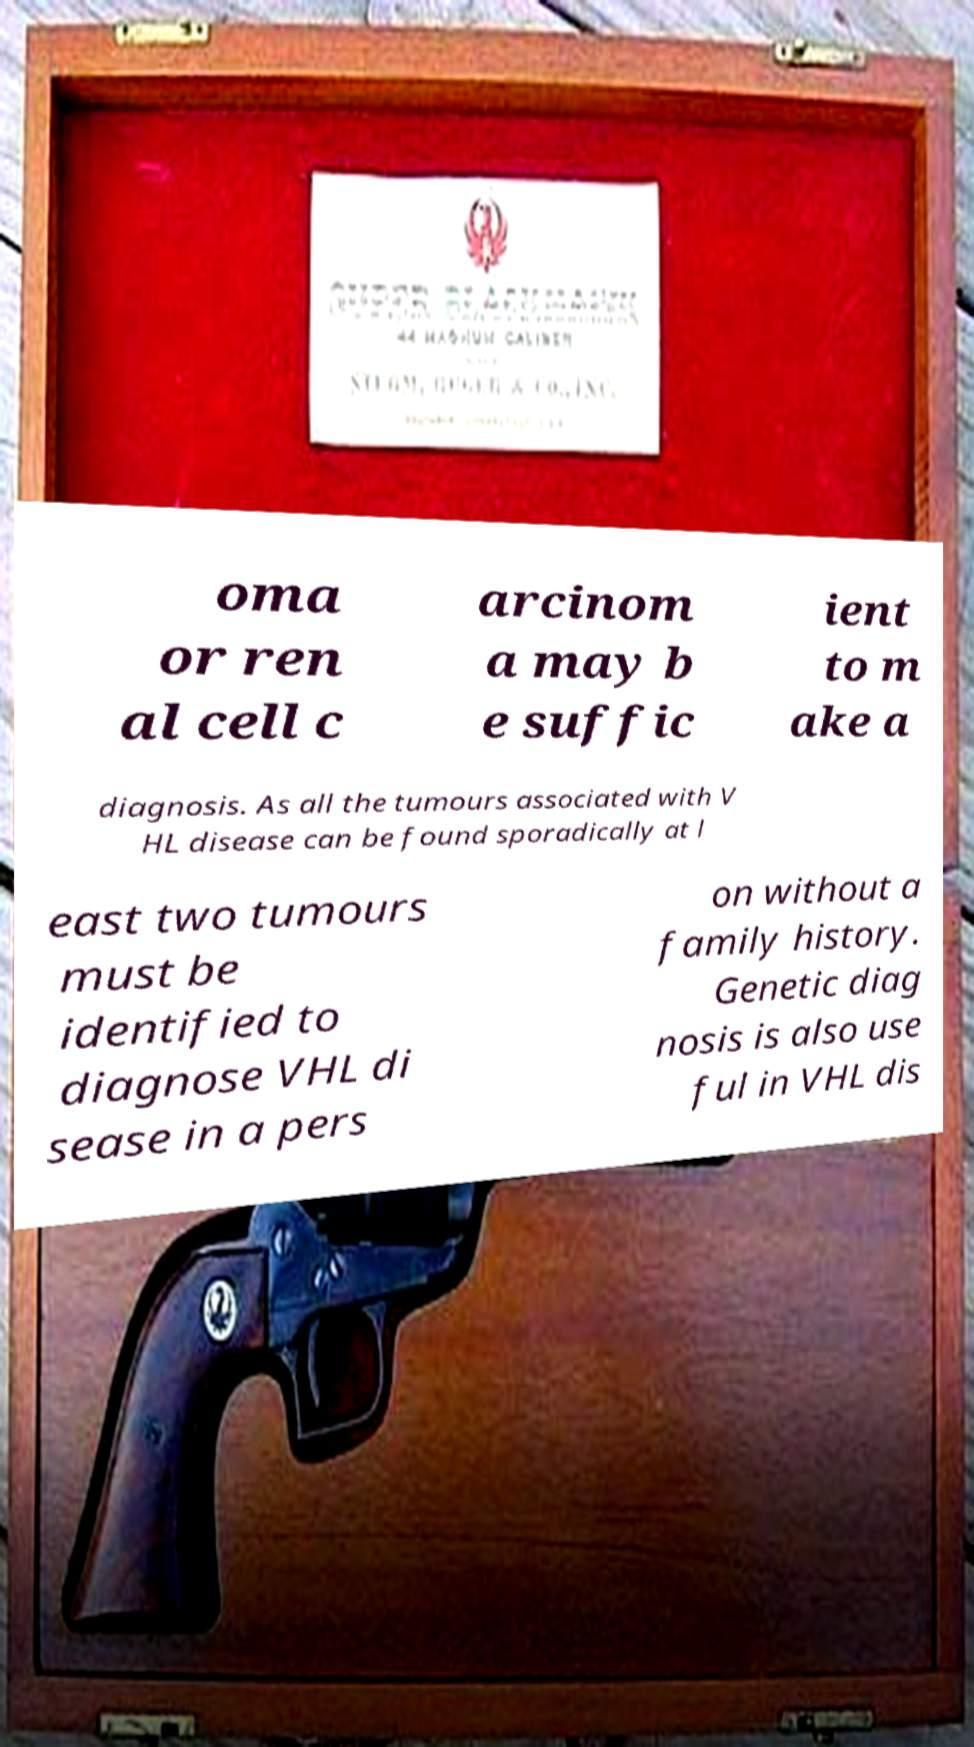Please read and relay the text visible in this image. What does it say? oma or ren al cell c arcinom a may b e suffic ient to m ake a diagnosis. As all the tumours associated with V HL disease can be found sporadically at l east two tumours must be identified to diagnose VHL di sease in a pers on without a family history. Genetic diag nosis is also use ful in VHL dis 